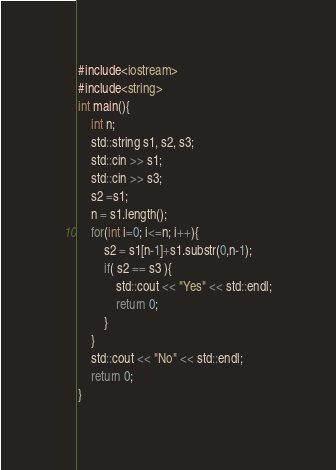Convert code to text. <code><loc_0><loc_0><loc_500><loc_500><_C++_>#include<iostream>
#include<string>
int main(){
    int n;
    std::string s1, s2, s3;
    std::cin >> s1;
    std::cin >> s3;
    s2 =s1;
    n = s1.length();
    for(int i=0; i<=n; i++){
        s2 = s1[n-1]+s1.substr(0,n-1);
        if( s2 == s3 ){
            std::cout << "Yes" << std::endl;
            return 0;
        }
    }   
    std::cout << "No" << std::endl;
    return 0;
}
</code> 